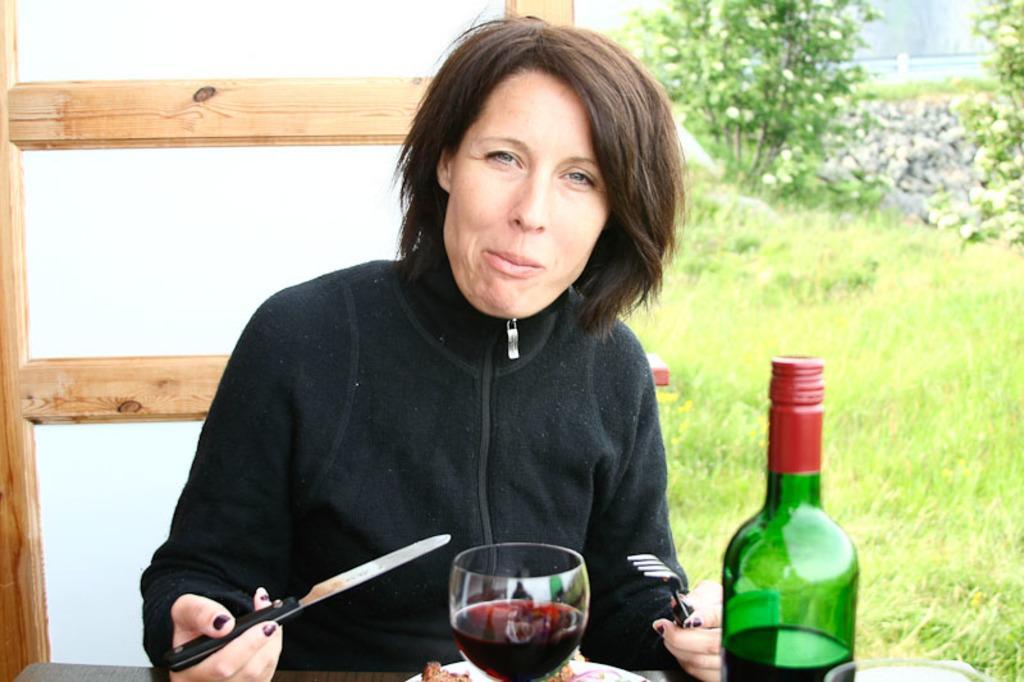Can you describe this image briefly? In the middle of the image, there is a woman sitting on the chair at dining table on which glass and a beverage bottle is kept. In the left side of the image, door is visible. In the right side of the image, grass is visible and trees are visible. In the top most right, water is visible. This image is taken during day time in a sunny day. 